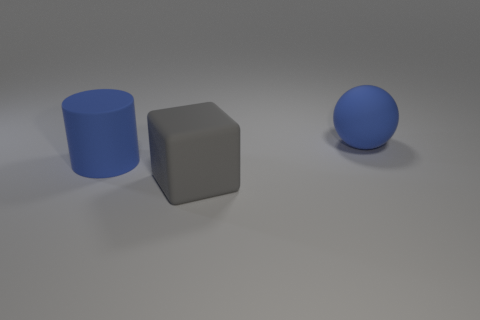Can you describe the lighting and shadows in the scene? The scene is illuminated in a way that creates soft shadows to the right of each object. This suggests a light source coming from the left side. The shadows are slightly blurred, indicating the light source is not extremely close to the objects. 